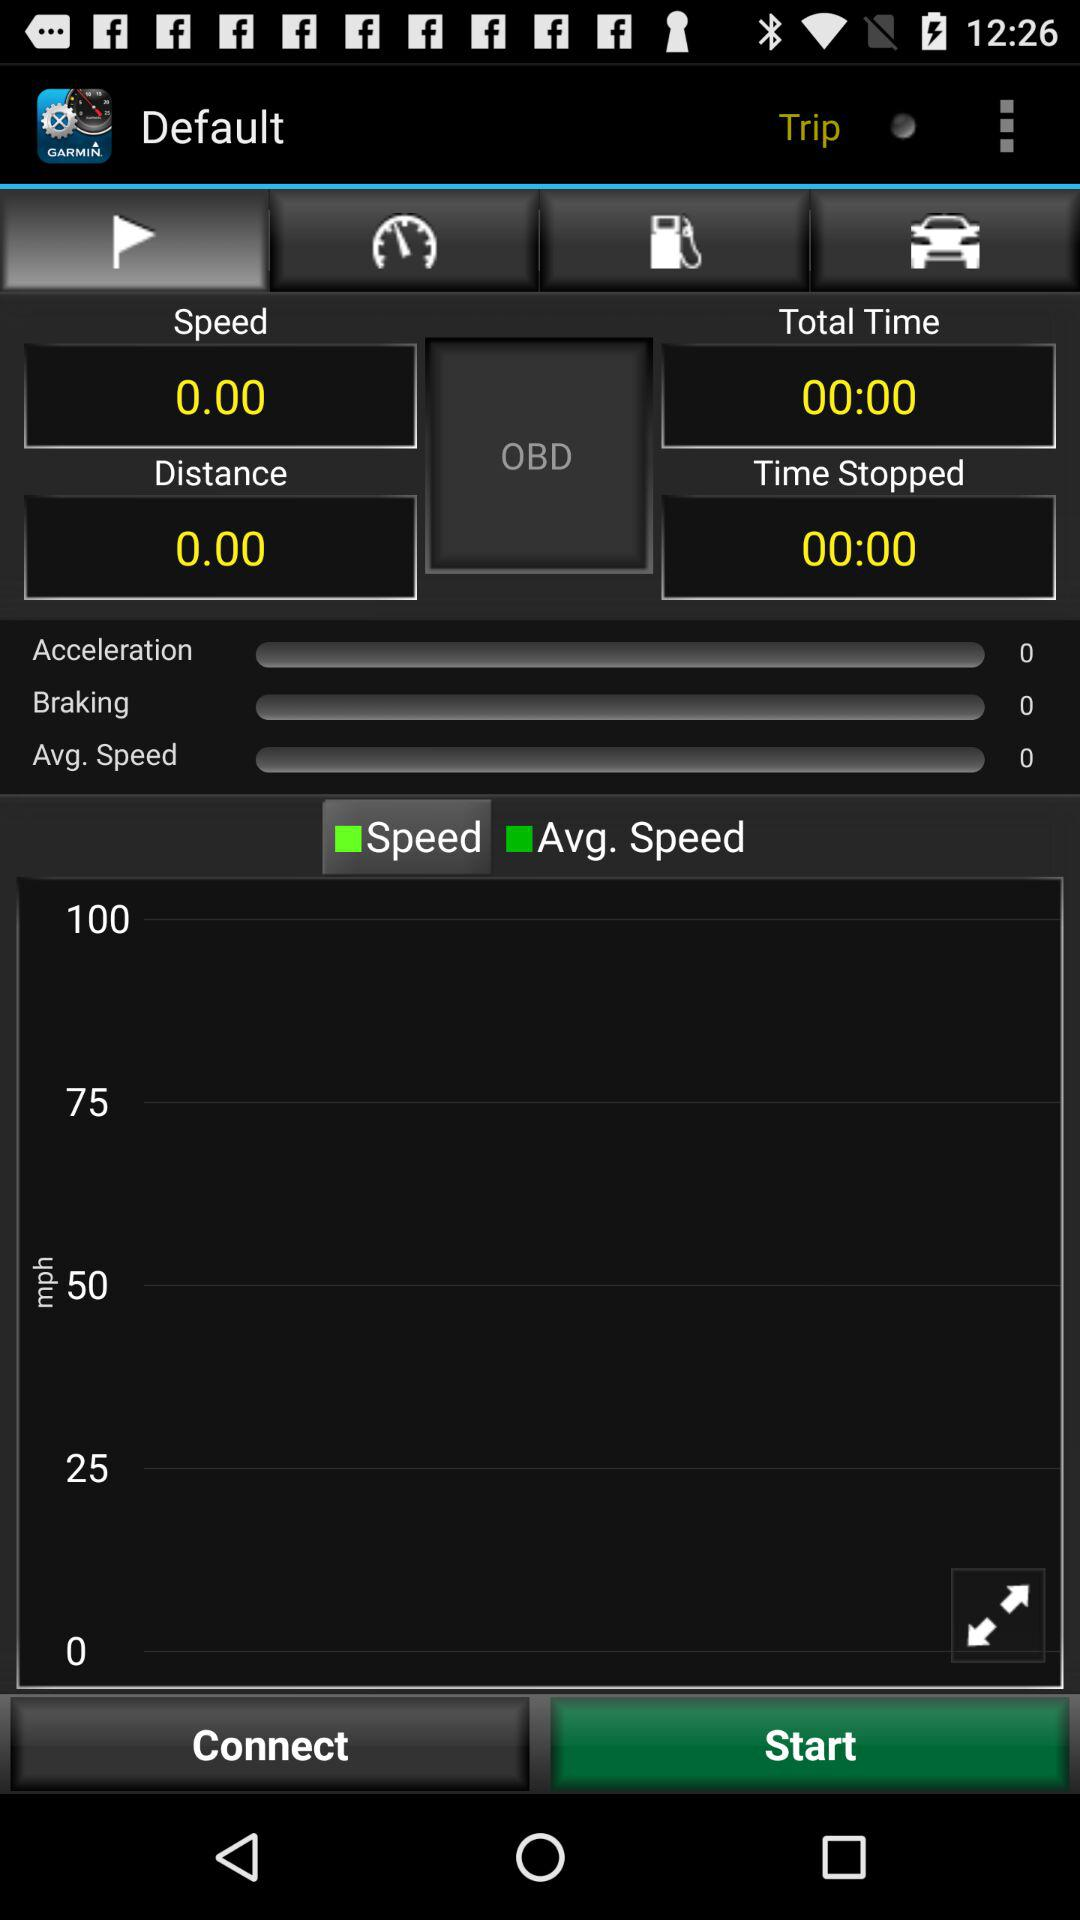How much time has elapsed since the last time the car stopped?
Answer the question using a single word or phrase. 00:00 